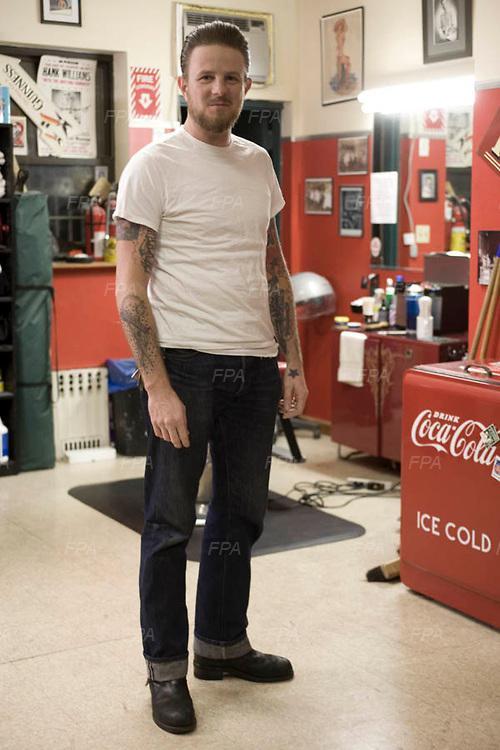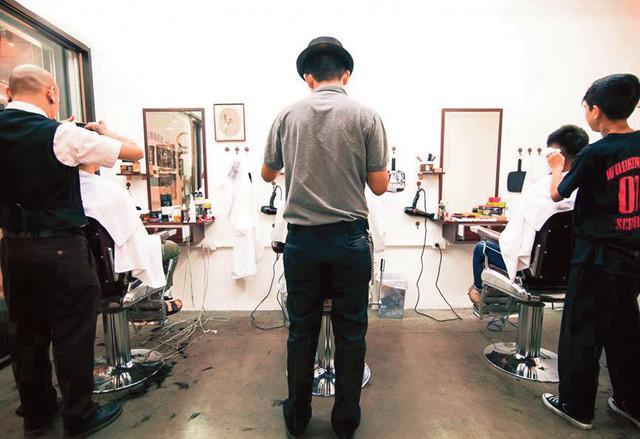The first image is the image on the left, the second image is the image on the right. Evaluate the accuracy of this statement regarding the images: "In one of the images, a man stands alone with no one else present.". Is it true? Answer yes or no. Yes. The first image is the image on the left, the second image is the image on the right. Assess this claim about the two images: "The image on the right has no more than one person wearing a hat.". Correct or not? Answer yes or no. Yes. 